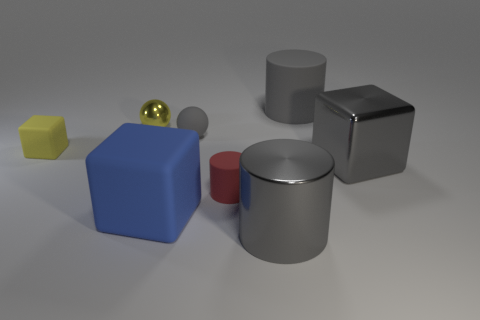Add 1 tiny yellow matte objects. How many objects exist? 9 Subtract all spheres. How many objects are left? 6 Subtract all tiny yellow objects. Subtract all large rubber things. How many objects are left? 4 Add 1 rubber spheres. How many rubber spheres are left? 2 Add 7 blocks. How many blocks exist? 10 Subtract 0 cyan blocks. How many objects are left? 8 